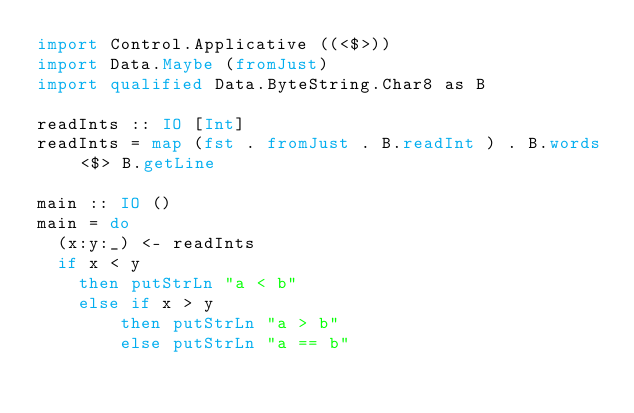Convert code to text. <code><loc_0><loc_0><loc_500><loc_500><_Haskell_>import Control.Applicative ((<$>))
import Data.Maybe (fromJust)
import qualified Data.ByteString.Char8 as B

readInts :: IO [Int]
readInts = map (fst . fromJust . B.readInt ) . B.words <$> B.getLine

main :: IO ()
main = do
  (x:y:_) <- readInts
  if x < y
    then putStrLn "a < b"
    else if x > y
        then putStrLn "a > b"
        else putStrLn "a == b"
</code> 